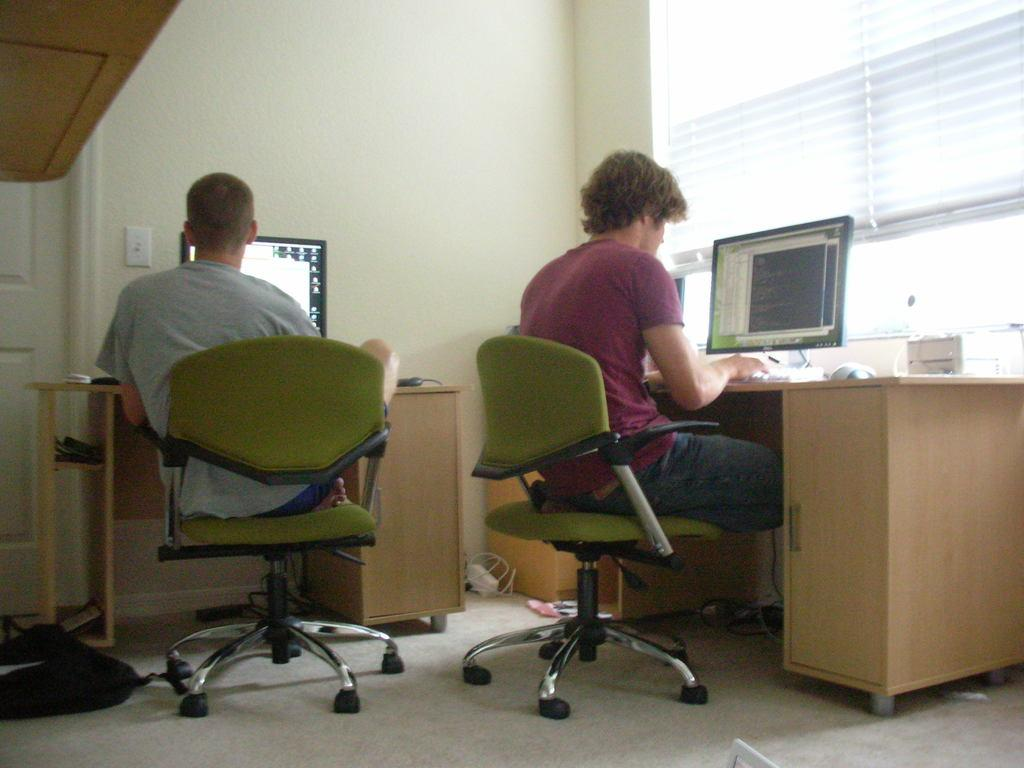How many persons are sitting in the image? There are two persons sitting in the image. What are the persons sitting on? The persons are sitting on green chairs. What objects are present on the tables in front of the chairs? Monitors, keyboards, and mice are present on the tables. What is on the floor in the image? There is a bag on the floor. What can be seen through the window in the image? The window in the image provides a view of the outside environment. What type of trousers is the person wearing on the left side of the image? There is no information provided about the type of trousers the person is wearing in the image. How many people were crushed in the image? There is no indication of any person being crushed in the image. 